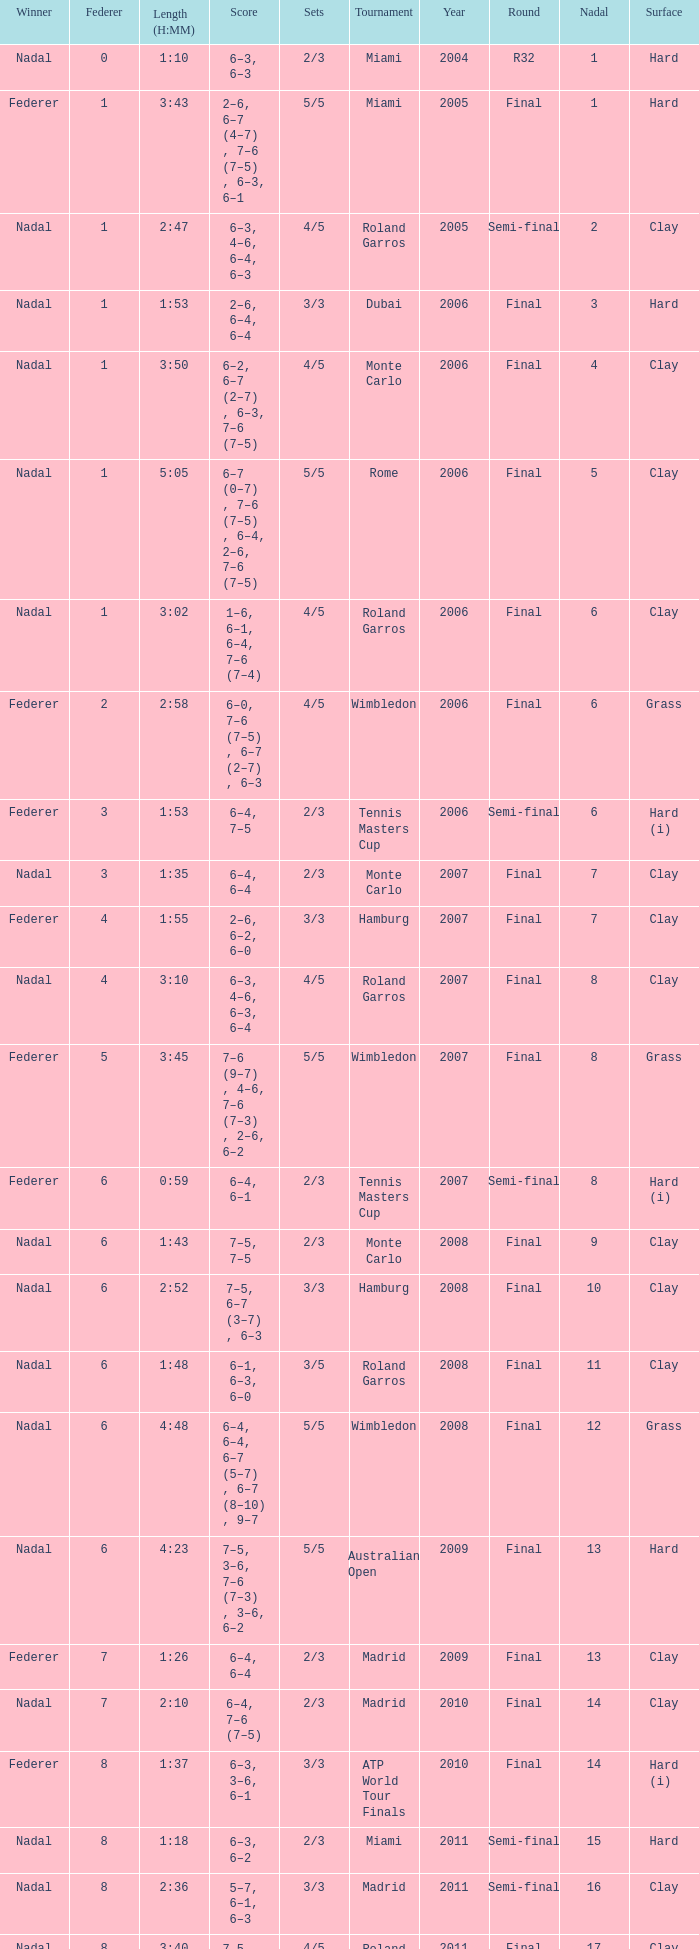What were the sets when Federer had 6 and a nadal of 13? 5/5. 